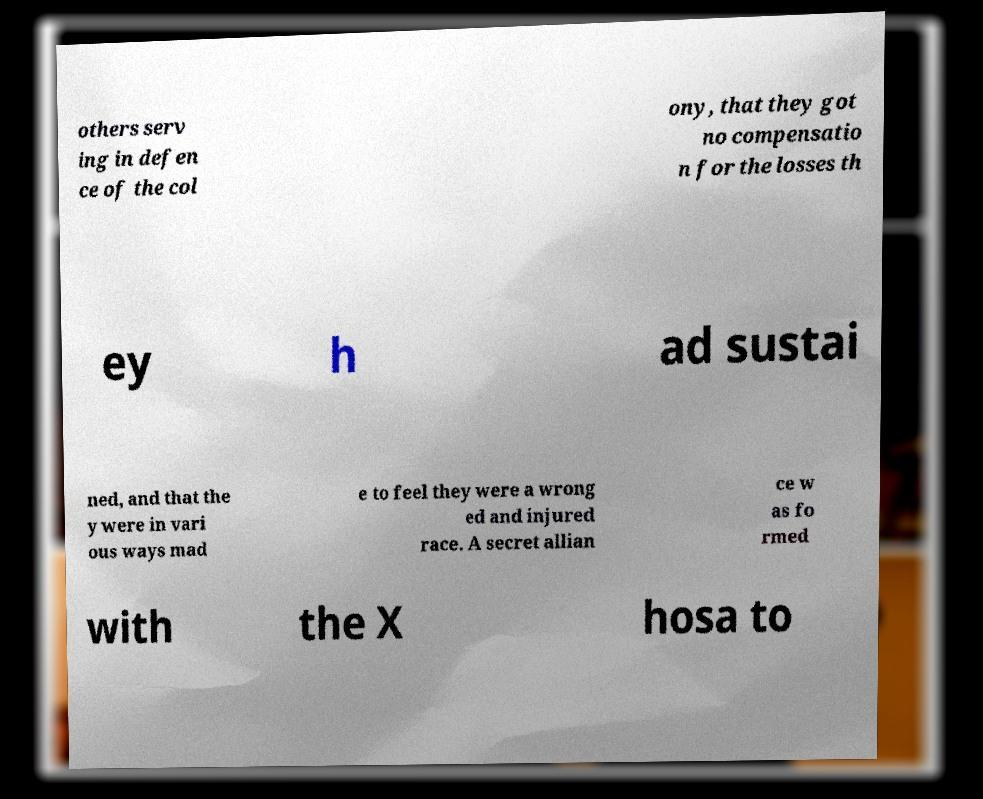For documentation purposes, I need the text within this image transcribed. Could you provide that? others serv ing in defen ce of the col ony, that they got no compensatio n for the losses th ey h ad sustai ned, and that the y were in vari ous ways mad e to feel they were a wrong ed and injured race. A secret allian ce w as fo rmed with the X hosa to 